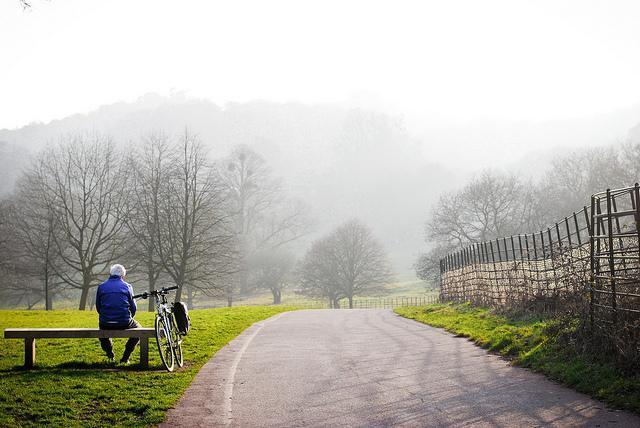How many benches are there?
Give a very brief answer. 1. How many people are there?
Give a very brief answer. 1. How many signs have bus icon on a pole?
Give a very brief answer. 0. 